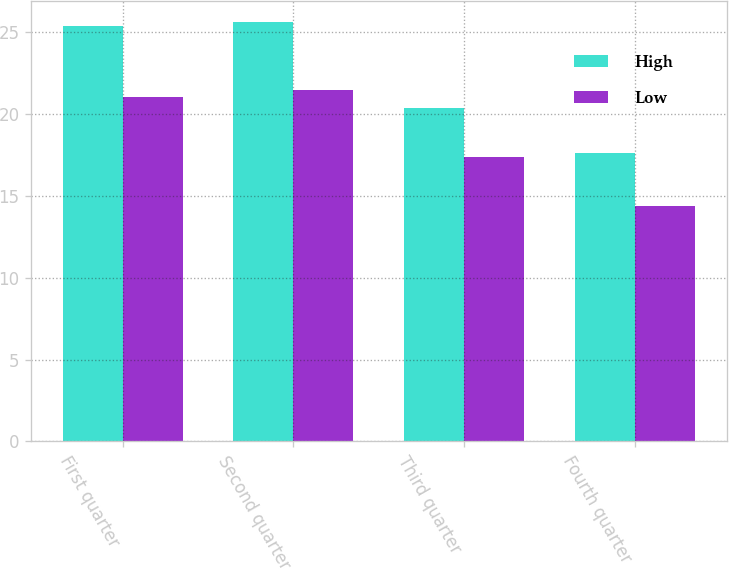<chart> <loc_0><loc_0><loc_500><loc_500><stacked_bar_chart><ecel><fcel>First quarter<fcel>Second quarter<fcel>Third quarter<fcel>Fourth quarter<nl><fcel>High<fcel>25.4<fcel>25.63<fcel>20.38<fcel>17.62<nl><fcel>Low<fcel>21.04<fcel>21.49<fcel>17.37<fcel>14.37<nl></chart> 